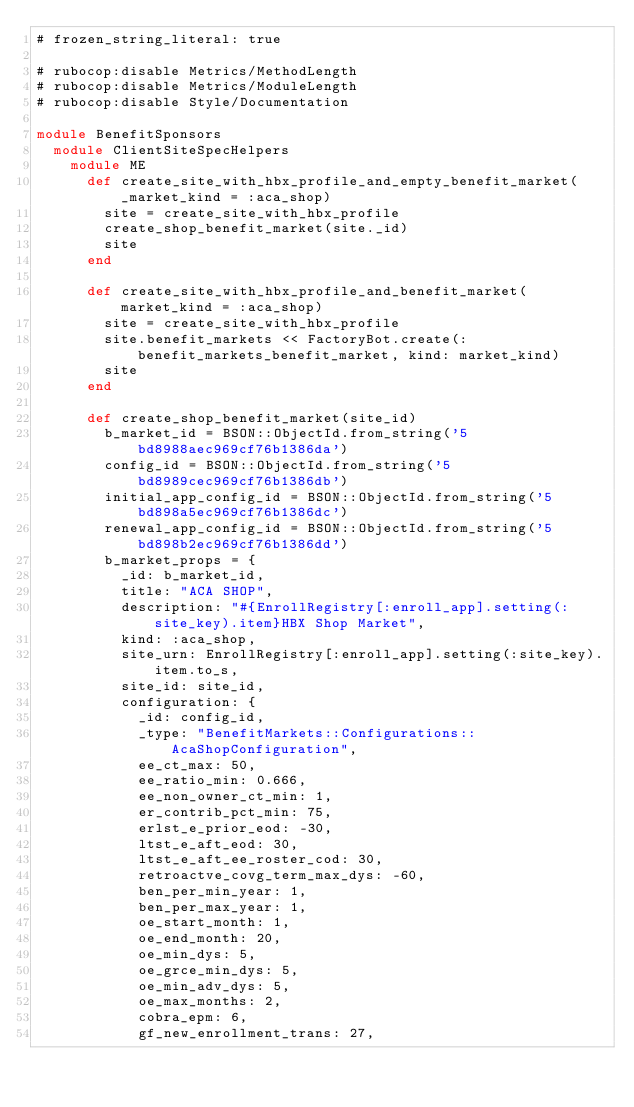Convert code to text. <code><loc_0><loc_0><loc_500><loc_500><_Ruby_># frozen_string_literal: true

# rubocop:disable Metrics/MethodLength
# rubocop:disable Metrics/ModuleLength
# rubocop:disable Style/Documentation

module BenefitSponsors
  module ClientSiteSpecHelpers
    module ME
      def create_site_with_hbx_profile_and_empty_benefit_market(_market_kind = :aca_shop)
        site = create_site_with_hbx_profile
        create_shop_benefit_market(site._id)
        site
      end

      def create_site_with_hbx_profile_and_benefit_market(market_kind = :aca_shop)
        site = create_site_with_hbx_profile
        site.benefit_markets << FactoryBot.create(:benefit_markets_benefit_market, kind: market_kind)
        site
      end

      def create_shop_benefit_market(site_id)
        b_market_id = BSON::ObjectId.from_string('5bd8988aec969cf76b1386da')
        config_id = BSON::ObjectId.from_string('5bd8989cec969cf76b1386db')
        initial_app_config_id = BSON::ObjectId.from_string('5bd898a5ec969cf76b1386dc')
        renewal_app_config_id = BSON::ObjectId.from_string('5bd898b2ec969cf76b1386dd')
        b_market_props = {
          _id: b_market_id,
          title: "ACA SHOP",
          description: "#{EnrollRegistry[:enroll_app].setting(:site_key).item}HBX Shop Market",
          kind: :aca_shop,
          site_urn: EnrollRegistry[:enroll_app].setting(:site_key).item.to_s,
          site_id: site_id,
          configuration: {
            _id: config_id,
            _type: "BenefitMarkets::Configurations::AcaShopConfiguration",
            ee_ct_max: 50,
            ee_ratio_min: 0.666,
            ee_non_owner_ct_min: 1,
            er_contrib_pct_min: 75,
            erlst_e_prior_eod: -30,
            ltst_e_aft_eod: 30,
            ltst_e_aft_ee_roster_cod: 30,
            retroactve_covg_term_max_dys: -60,
            ben_per_min_year: 1,
            ben_per_max_year: 1,
            oe_start_month: 1,
            oe_end_month: 20,
            oe_min_dys: 5,
            oe_grce_min_dys: 5,
            oe_min_adv_dys: 5,
            oe_max_months: 2,
            cobra_epm: 6,
            gf_new_enrollment_trans: 27,</code> 